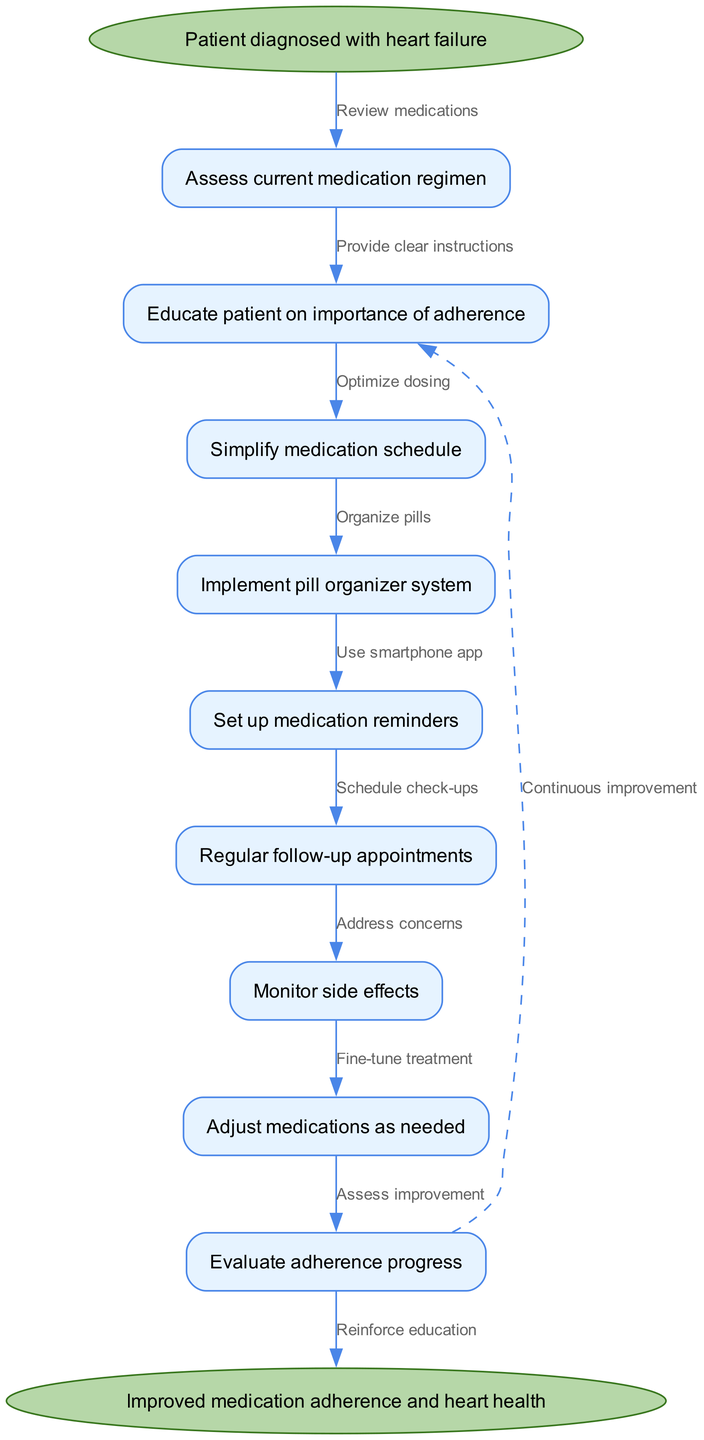What is the starting point of the flow chart? The starting point, or initial node, of the flow chart is where the process begins, which is represented by "Patient diagnosed with heart failure."
Answer: Patient diagnosed with heart failure How many nodes are there in the diagram? There is a total of 10 nodes in the diagram including the start and end nodes, plus the 8 intermediate nodes outlining the steps.
Answer: 10 What is the last step before reaching the end node? The last step before reaching the end node is "Evaluate adherence progress," which is the final action taken in the flowchart before achieving improved medication adherence and heart health.
Answer: Evaluate adherence progress What connects "Regular follow-up appointments" to "Monitor side effects"? The edge connecting these two nodes is labeled "Schedule check-ups," indicating that regular follow-up appointments are linked to monitoring side effects through scheduled check-ups.
Answer: Schedule check-ups What is the purpose of the dashed line in the diagram? The dashed line represents a feedback loop, indicating that after "Evaluate adherence progress," the process may cycle back to "Educate patient on importance of adherence" for continuous improvement.
Answer: Continuous improvement Which node involves simplification of the medication regimen? The node that involves simplification of the medication regimen is "Simplify medication schedule," which focuses on making it easier for patients to adhere to their medication.
Answer: Simplify medication schedule How many edges originate from the "Assess current medication regimen" node? There is one edge that originates from the "Assess current medication regimen" node, leading to the next step in the flow of actions.
Answer: 1 What happens after "Monitor side effects"? After "Monitor side effects," the next step is "Adjust medications as needed," indicating the process of making necessary changes based on the patient's experience.
Answer: Adjust medications as needed 